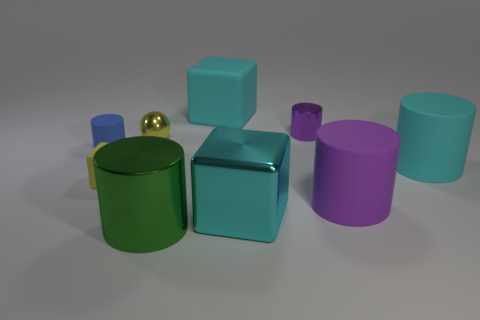Subtract all gray cubes. How many purple cylinders are left? 2 Subtract all metal cylinders. How many cylinders are left? 3 Subtract all green cylinders. How many cylinders are left? 4 Subtract 1 blocks. How many blocks are left? 2 Subtract all green cylinders. Subtract all yellow balls. How many cylinders are left? 4 Add 1 tiny blue cylinders. How many objects exist? 10 Subtract all cubes. How many objects are left? 6 Add 6 tiny brown cylinders. How many tiny brown cylinders exist? 6 Subtract 0 cyan balls. How many objects are left? 9 Subtract all cyan objects. Subtract all green cylinders. How many objects are left? 5 